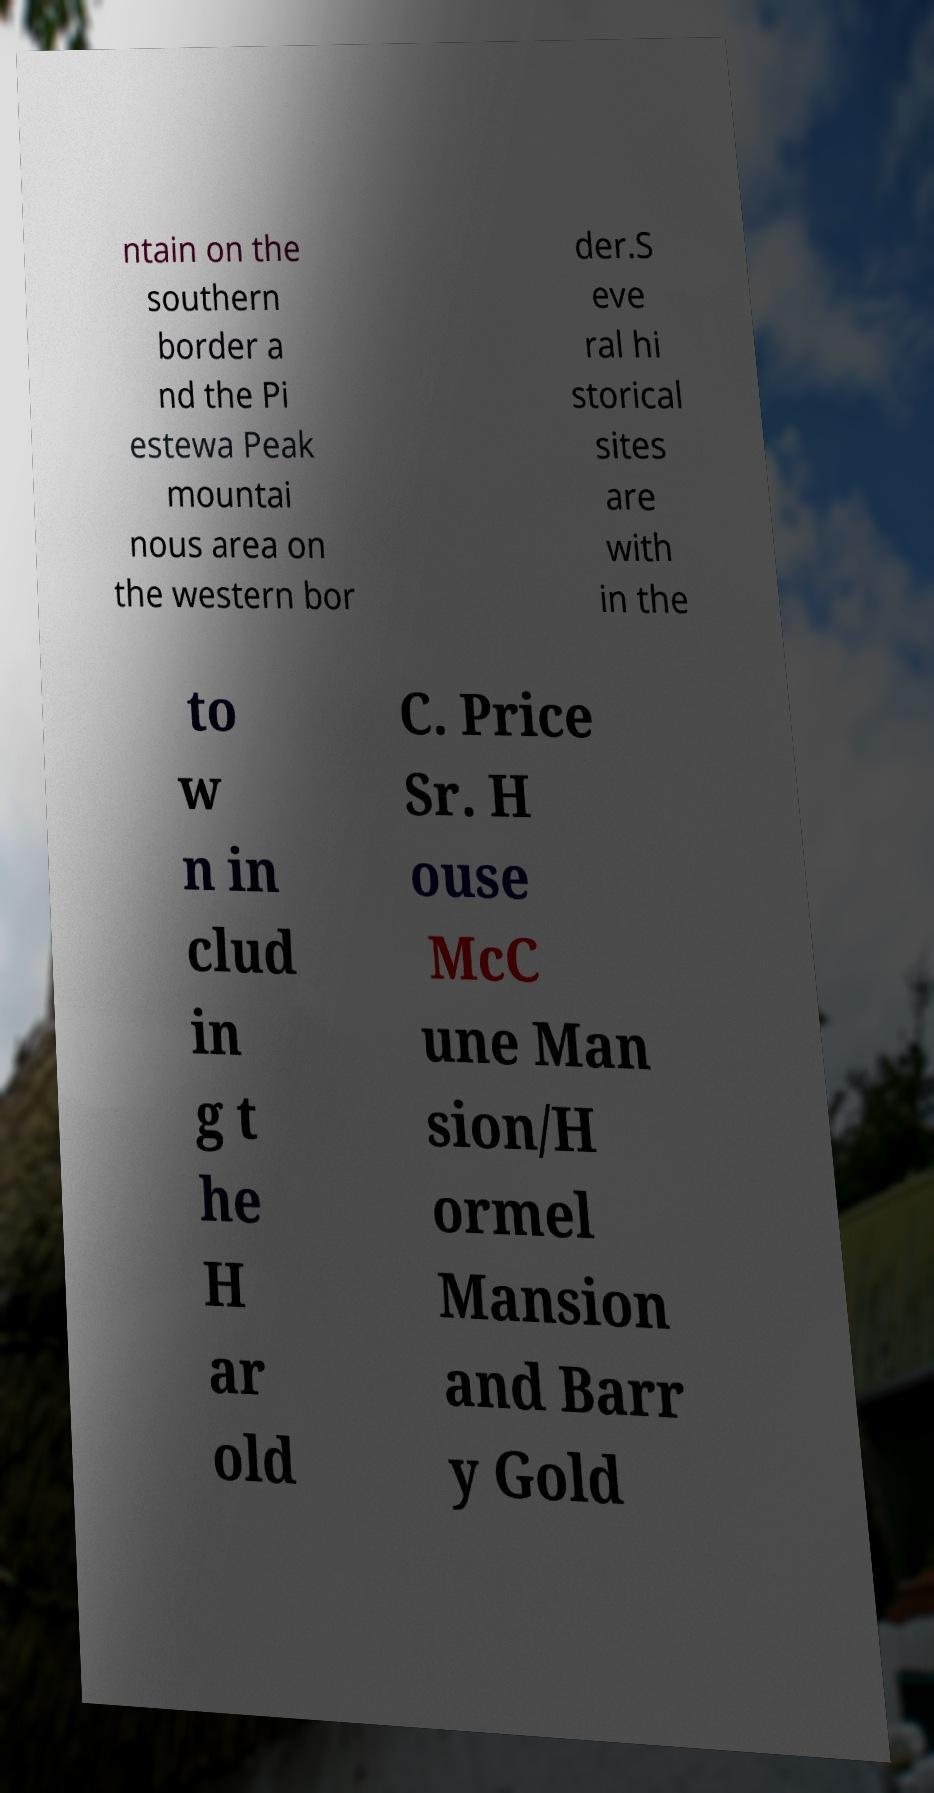Please identify and transcribe the text found in this image. ntain on the southern border a nd the Pi estewa Peak mountai nous area on the western bor der.S eve ral hi storical sites are with in the to w n in clud in g t he H ar old C. Price Sr. H ouse McC une Man sion/H ormel Mansion and Barr y Gold 